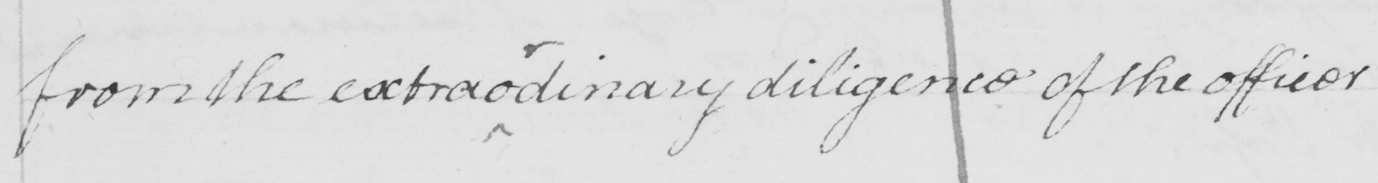Transcribe the text shown in this historical manuscript line. from the extraordinary diligence of the officer 